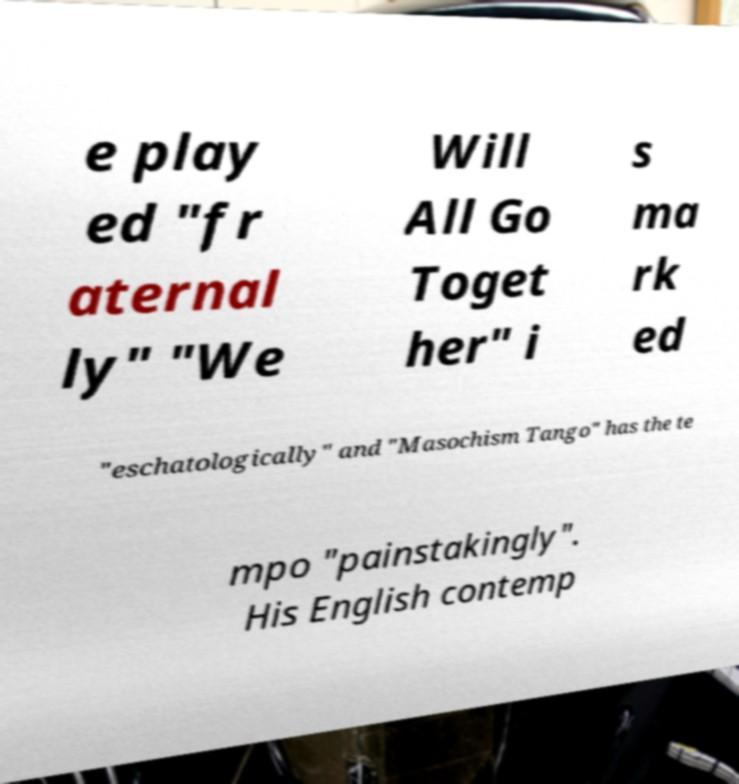Could you extract and type out the text from this image? e play ed "fr aternal ly" "We Will All Go Toget her" i s ma rk ed "eschatologically" and "Masochism Tango" has the te mpo "painstakingly". His English contemp 